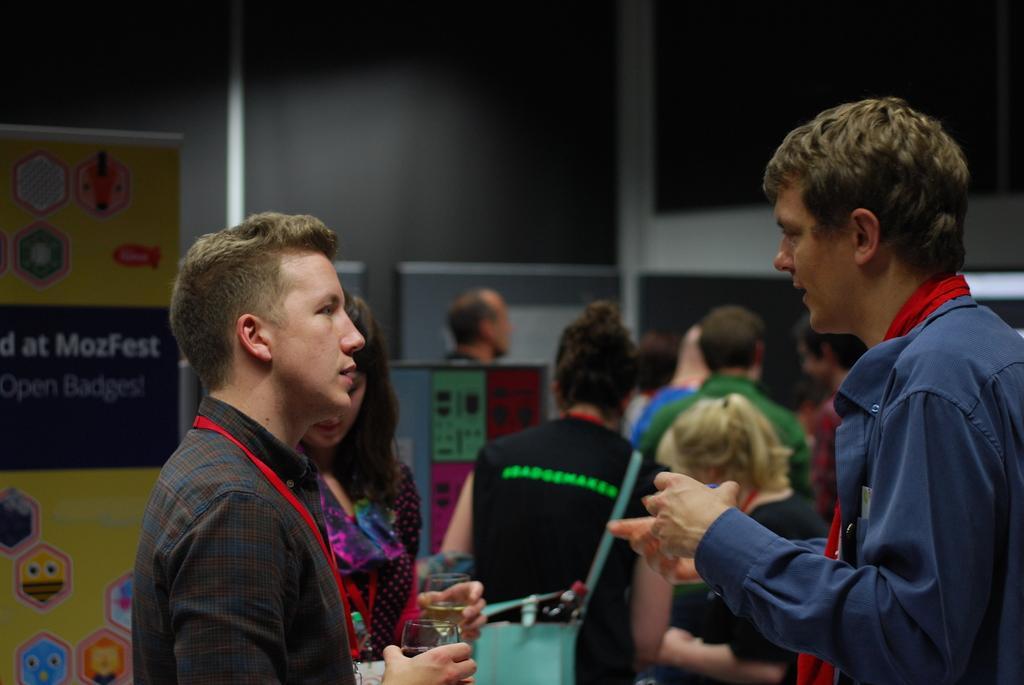Could you give a brief overview of what you see in this image? In the background we can see a person standing and it seems like a board. On the left side of the picture we can see a board. In this picture we can see people standing and few are holding glasses in their hands. 